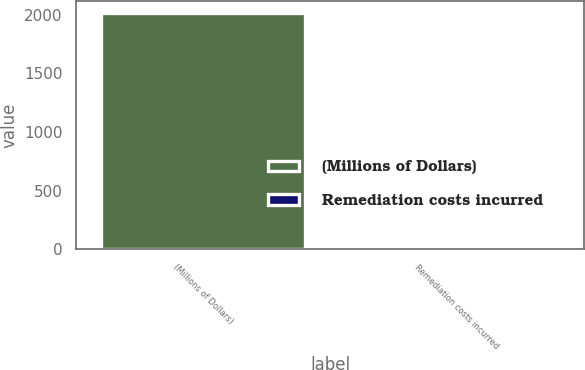Convert chart. <chart><loc_0><loc_0><loc_500><loc_500><bar_chart><fcel>(Millions of Dollars)<fcel>Remediation costs incurred<nl><fcel>2012<fcel>31<nl></chart> 